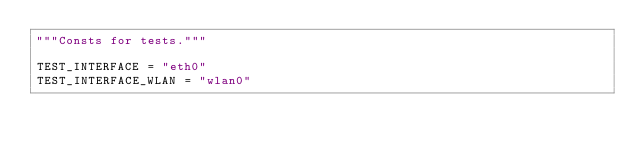<code> <loc_0><loc_0><loc_500><loc_500><_Python_>"""Consts for tests."""

TEST_INTERFACE = "eth0"
TEST_INTERFACE_WLAN = "wlan0"
</code> 